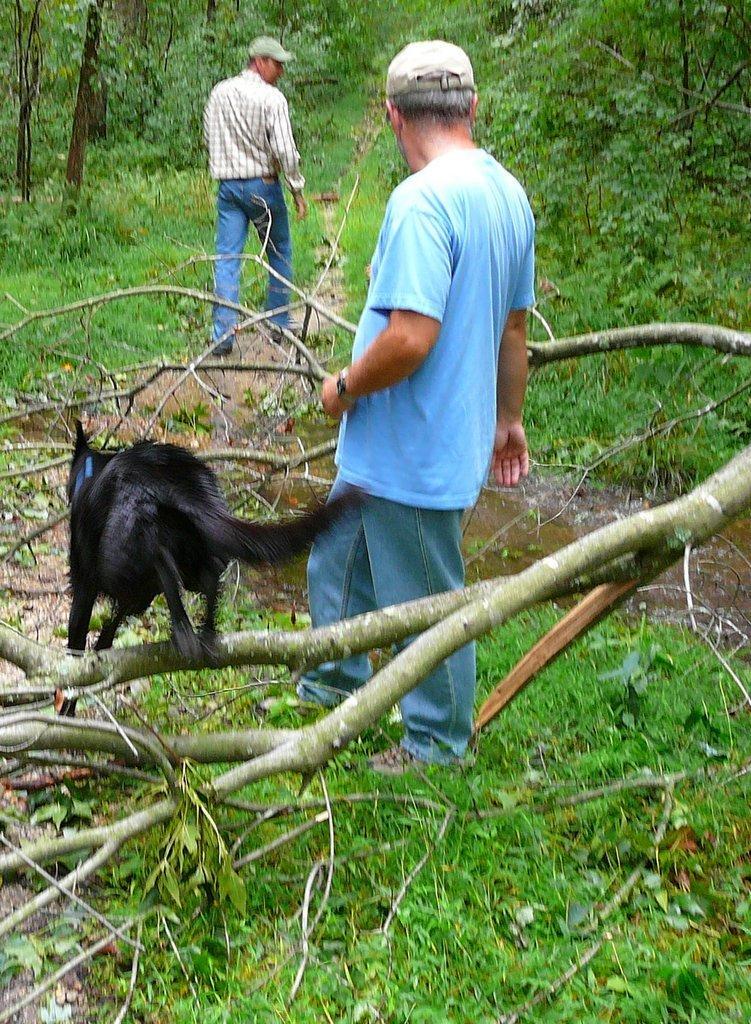Can you describe this image briefly? In this image we can see two persons and a dog, there are plants, trees, and grass, also we can see the water. 